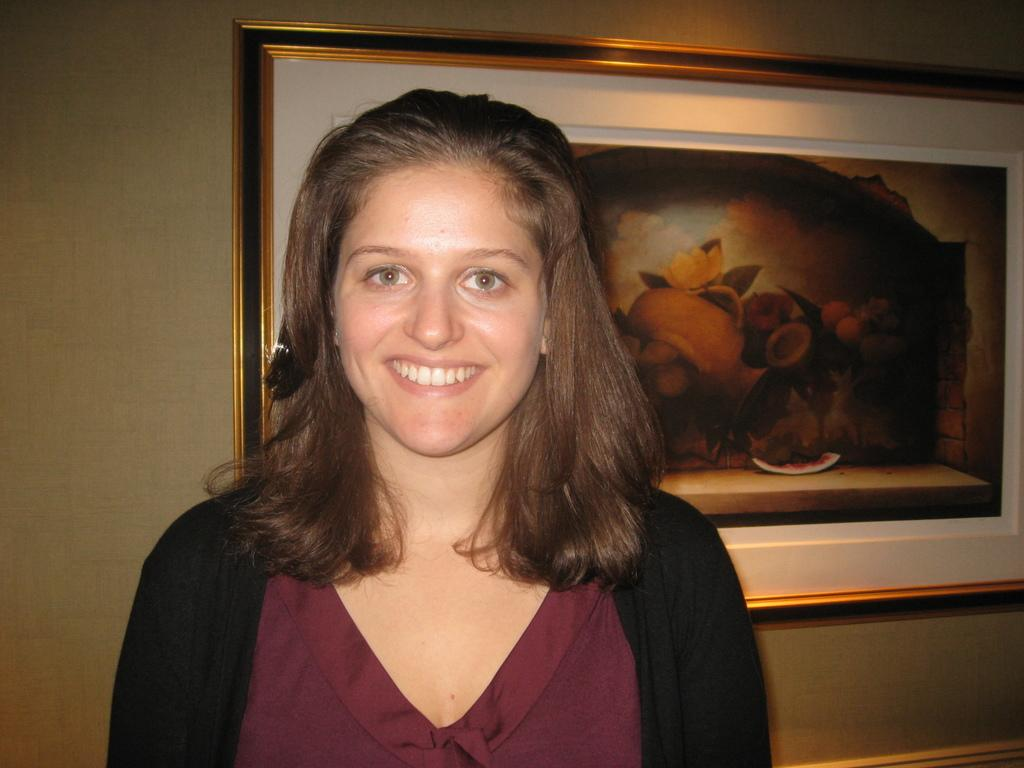Who is present in the image? There is a woman in the image. What expression does the woman have? The woman is smiling. What can be seen in the background of the image? There is a frame on the wall in the background of the image. How many thumbs can be seen on the woman's hands in the image? There is no visible thumb on the woman's hands in the image. What type of card is the woman holding in the image? There is no card present in the image. 